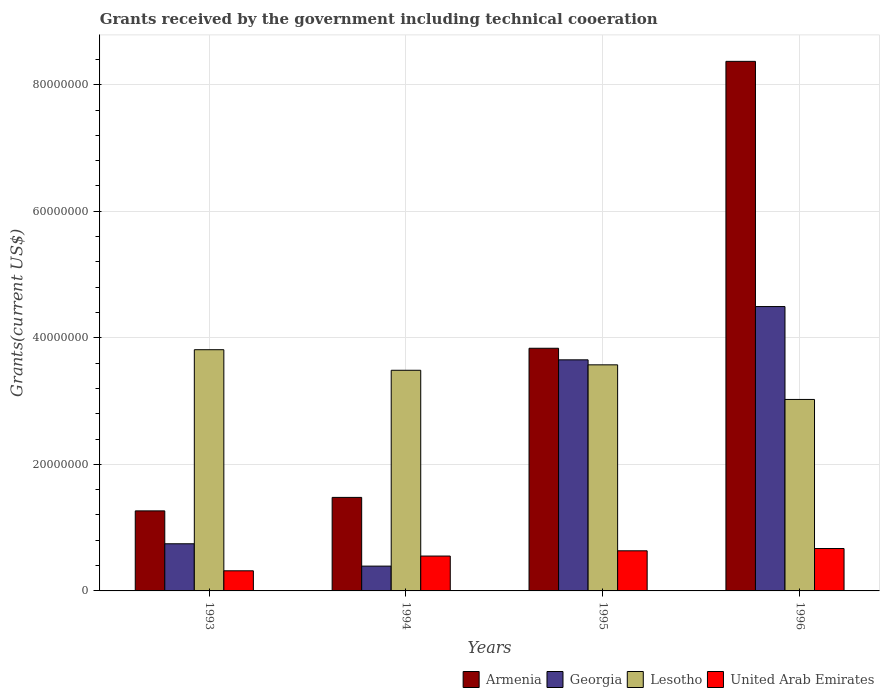How many different coloured bars are there?
Provide a succinct answer. 4. Are the number of bars on each tick of the X-axis equal?
Provide a succinct answer. Yes. What is the label of the 1st group of bars from the left?
Provide a short and direct response. 1993. In how many cases, is the number of bars for a given year not equal to the number of legend labels?
Offer a very short reply. 0. What is the total grants received by the government in Armenia in 1994?
Provide a short and direct response. 1.48e+07. Across all years, what is the maximum total grants received by the government in Lesotho?
Ensure brevity in your answer.  3.81e+07. Across all years, what is the minimum total grants received by the government in Armenia?
Keep it short and to the point. 1.26e+07. What is the total total grants received by the government in Armenia in the graph?
Ensure brevity in your answer.  1.49e+08. What is the difference between the total grants received by the government in United Arab Emirates in 1993 and that in 1996?
Provide a short and direct response. -3.52e+06. What is the difference between the total grants received by the government in United Arab Emirates in 1996 and the total grants received by the government in Armenia in 1994?
Your answer should be compact. -8.08e+06. What is the average total grants received by the government in Armenia per year?
Your answer should be compact. 3.74e+07. In the year 1993, what is the difference between the total grants received by the government in Georgia and total grants received by the government in Lesotho?
Keep it short and to the point. -3.07e+07. What is the ratio of the total grants received by the government in Lesotho in 1993 to that in 1996?
Provide a succinct answer. 1.26. Is the difference between the total grants received by the government in Georgia in 1993 and 1995 greater than the difference between the total grants received by the government in Lesotho in 1993 and 1995?
Provide a succinct answer. No. What is the difference between the highest and the second highest total grants received by the government in Georgia?
Offer a very short reply. 8.42e+06. What is the difference between the highest and the lowest total grants received by the government in Lesotho?
Make the answer very short. 7.86e+06. What does the 4th bar from the left in 1993 represents?
Offer a terse response. United Arab Emirates. What does the 2nd bar from the right in 1993 represents?
Your answer should be compact. Lesotho. Are all the bars in the graph horizontal?
Your response must be concise. No. What is the difference between two consecutive major ticks on the Y-axis?
Your answer should be very brief. 2.00e+07. Are the values on the major ticks of Y-axis written in scientific E-notation?
Offer a terse response. No. Does the graph contain grids?
Ensure brevity in your answer.  Yes. Where does the legend appear in the graph?
Ensure brevity in your answer.  Bottom right. What is the title of the graph?
Give a very brief answer. Grants received by the government including technical cooeration. What is the label or title of the Y-axis?
Your answer should be compact. Grants(current US$). What is the Grants(current US$) of Armenia in 1993?
Give a very brief answer. 1.26e+07. What is the Grants(current US$) in Georgia in 1993?
Make the answer very short. 7.45e+06. What is the Grants(current US$) in Lesotho in 1993?
Your answer should be compact. 3.81e+07. What is the Grants(current US$) of United Arab Emirates in 1993?
Make the answer very short. 3.18e+06. What is the Grants(current US$) in Armenia in 1994?
Offer a very short reply. 1.48e+07. What is the Grants(current US$) in Georgia in 1994?
Offer a terse response. 3.92e+06. What is the Grants(current US$) in Lesotho in 1994?
Your answer should be very brief. 3.49e+07. What is the Grants(current US$) in United Arab Emirates in 1994?
Make the answer very short. 5.51e+06. What is the Grants(current US$) in Armenia in 1995?
Offer a very short reply. 3.84e+07. What is the Grants(current US$) in Georgia in 1995?
Offer a very short reply. 3.65e+07. What is the Grants(current US$) of Lesotho in 1995?
Give a very brief answer. 3.57e+07. What is the Grants(current US$) in United Arab Emirates in 1995?
Offer a terse response. 6.34e+06. What is the Grants(current US$) in Armenia in 1996?
Keep it short and to the point. 8.37e+07. What is the Grants(current US$) in Georgia in 1996?
Your response must be concise. 4.49e+07. What is the Grants(current US$) in Lesotho in 1996?
Offer a very short reply. 3.03e+07. What is the Grants(current US$) in United Arab Emirates in 1996?
Give a very brief answer. 6.70e+06. Across all years, what is the maximum Grants(current US$) in Armenia?
Offer a terse response. 8.37e+07. Across all years, what is the maximum Grants(current US$) in Georgia?
Offer a terse response. 4.49e+07. Across all years, what is the maximum Grants(current US$) in Lesotho?
Provide a succinct answer. 3.81e+07. Across all years, what is the maximum Grants(current US$) of United Arab Emirates?
Make the answer very short. 6.70e+06. Across all years, what is the minimum Grants(current US$) in Armenia?
Provide a succinct answer. 1.26e+07. Across all years, what is the minimum Grants(current US$) of Georgia?
Make the answer very short. 3.92e+06. Across all years, what is the minimum Grants(current US$) of Lesotho?
Provide a short and direct response. 3.03e+07. Across all years, what is the minimum Grants(current US$) of United Arab Emirates?
Give a very brief answer. 3.18e+06. What is the total Grants(current US$) of Armenia in the graph?
Your response must be concise. 1.49e+08. What is the total Grants(current US$) of Georgia in the graph?
Your response must be concise. 9.28e+07. What is the total Grants(current US$) in Lesotho in the graph?
Ensure brevity in your answer.  1.39e+08. What is the total Grants(current US$) in United Arab Emirates in the graph?
Ensure brevity in your answer.  2.17e+07. What is the difference between the Grants(current US$) of Armenia in 1993 and that in 1994?
Provide a succinct answer. -2.13e+06. What is the difference between the Grants(current US$) in Georgia in 1993 and that in 1994?
Your answer should be compact. 3.53e+06. What is the difference between the Grants(current US$) in Lesotho in 1993 and that in 1994?
Offer a terse response. 3.25e+06. What is the difference between the Grants(current US$) of United Arab Emirates in 1993 and that in 1994?
Your response must be concise. -2.33e+06. What is the difference between the Grants(current US$) in Armenia in 1993 and that in 1995?
Your answer should be compact. -2.57e+07. What is the difference between the Grants(current US$) in Georgia in 1993 and that in 1995?
Offer a terse response. -2.91e+07. What is the difference between the Grants(current US$) in Lesotho in 1993 and that in 1995?
Make the answer very short. 2.39e+06. What is the difference between the Grants(current US$) of United Arab Emirates in 1993 and that in 1995?
Provide a short and direct response. -3.16e+06. What is the difference between the Grants(current US$) in Armenia in 1993 and that in 1996?
Keep it short and to the point. -7.10e+07. What is the difference between the Grants(current US$) of Georgia in 1993 and that in 1996?
Keep it short and to the point. -3.75e+07. What is the difference between the Grants(current US$) of Lesotho in 1993 and that in 1996?
Offer a very short reply. 7.86e+06. What is the difference between the Grants(current US$) in United Arab Emirates in 1993 and that in 1996?
Give a very brief answer. -3.52e+06. What is the difference between the Grants(current US$) of Armenia in 1994 and that in 1995?
Provide a succinct answer. -2.36e+07. What is the difference between the Grants(current US$) of Georgia in 1994 and that in 1995?
Offer a very short reply. -3.26e+07. What is the difference between the Grants(current US$) of Lesotho in 1994 and that in 1995?
Your response must be concise. -8.60e+05. What is the difference between the Grants(current US$) of United Arab Emirates in 1994 and that in 1995?
Provide a short and direct response. -8.30e+05. What is the difference between the Grants(current US$) in Armenia in 1994 and that in 1996?
Give a very brief answer. -6.89e+07. What is the difference between the Grants(current US$) in Georgia in 1994 and that in 1996?
Offer a very short reply. -4.10e+07. What is the difference between the Grants(current US$) in Lesotho in 1994 and that in 1996?
Give a very brief answer. 4.61e+06. What is the difference between the Grants(current US$) of United Arab Emirates in 1994 and that in 1996?
Provide a succinct answer. -1.19e+06. What is the difference between the Grants(current US$) in Armenia in 1995 and that in 1996?
Your answer should be very brief. -4.53e+07. What is the difference between the Grants(current US$) in Georgia in 1995 and that in 1996?
Your answer should be very brief. -8.42e+06. What is the difference between the Grants(current US$) of Lesotho in 1995 and that in 1996?
Provide a succinct answer. 5.47e+06. What is the difference between the Grants(current US$) of United Arab Emirates in 1995 and that in 1996?
Ensure brevity in your answer.  -3.60e+05. What is the difference between the Grants(current US$) in Armenia in 1993 and the Grants(current US$) in Georgia in 1994?
Your response must be concise. 8.73e+06. What is the difference between the Grants(current US$) in Armenia in 1993 and the Grants(current US$) in Lesotho in 1994?
Offer a terse response. -2.22e+07. What is the difference between the Grants(current US$) in Armenia in 1993 and the Grants(current US$) in United Arab Emirates in 1994?
Give a very brief answer. 7.14e+06. What is the difference between the Grants(current US$) in Georgia in 1993 and the Grants(current US$) in Lesotho in 1994?
Offer a very short reply. -2.74e+07. What is the difference between the Grants(current US$) in Georgia in 1993 and the Grants(current US$) in United Arab Emirates in 1994?
Your answer should be compact. 1.94e+06. What is the difference between the Grants(current US$) of Lesotho in 1993 and the Grants(current US$) of United Arab Emirates in 1994?
Your answer should be very brief. 3.26e+07. What is the difference between the Grants(current US$) in Armenia in 1993 and the Grants(current US$) in Georgia in 1995?
Make the answer very short. -2.39e+07. What is the difference between the Grants(current US$) in Armenia in 1993 and the Grants(current US$) in Lesotho in 1995?
Provide a succinct answer. -2.31e+07. What is the difference between the Grants(current US$) of Armenia in 1993 and the Grants(current US$) of United Arab Emirates in 1995?
Your answer should be compact. 6.31e+06. What is the difference between the Grants(current US$) of Georgia in 1993 and the Grants(current US$) of Lesotho in 1995?
Ensure brevity in your answer.  -2.83e+07. What is the difference between the Grants(current US$) of Georgia in 1993 and the Grants(current US$) of United Arab Emirates in 1995?
Make the answer very short. 1.11e+06. What is the difference between the Grants(current US$) of Lesotho in 1993 and the Grants(current US$) of United Arab Emirates in 1995?
Make the answer very short. 3.18e+07. What is the difference between the Grants(current US$) in Armenia in 1993 and the Grants(current US$) in Georgia in 1996?
Provide a short and direct response. -3.23e+07. What is the difference between the Grants(current US$) of Armenia in 1993 and the Grants(current US$) of Lesotho in 1996?
Ensure brevity in your answer.  -1.76e+07. What is the difference between the Grants(current US$) in Armenia in 1993 and the Grants(current US$) in United Arab Emirates in 1996?
Provide a succinct answer. 5.95e+06. What is the difference between the Grants(current US$) in Georgia in 1993 and the Grants(current US$) in Lesotho in 1996?
Your answer should be very brief. -2.28e+07. What is the difference between the Grants(current US$) of Georgia in 1993 and the Grants(current US$) of United Arab Emirates in 1996?
Provide a short and direct response. 7.50e+05. What is the difference between the Grants(current US$) in Lesotho in 1993 and the Grants(current US$) in United Arab Emirates in 1996?
Ensure brevity in your answer.  3.14e+07. What is the difference between the Grants(current US$) in Armenia in 1994 and the Grants(current US$) in Georgia in 1995?
Offer a very short reply. -2.17e+07. What is the difference between the Grants(current US$) in Armenia in 1994 and the Grants(current US$) in Lesotho in 1995?
Make the answer very short. -2.10e+07. What is the difference between the Grants(current US$) of Armenia in 1994 and the Grants(current US$) of United Arab Emirates in 1995?
Your answer should be very brief. 8.44e+06. What is the difference between the Grants(current US$) of Georgia in 1994 and the Grants(current US$) of Lesotho in 1995?
Your response must be concise. -3.18e+07. What is the difference between the Grants(current US$) in Georgia in 1994 and the Grants(current US$) in United Arab Emirates in 1995?
Provide a short and direct response. -2.42e+06. What is the difference between the Grants(current US$) of Lesotho in 1994 and the Grants(current US$) of United Arab Emirates in 1995?
Your answer should be compact. 2.85e+07. What is the difference between the Grants(current US$) of Armenia in 1994 and the Grants(current US$) of Georgia in 1996?
Ensure brevity in your answer.  -3.02e+07. What is the difference between the Grants(current US$) in Armenia in 1994 and the Grants(current US$) in Lesotho in 1996?
Make the answer very short. -1.55e+07. What is the difference between the Grants(current US$) in Armenia in 1994 and the Grants(current US$) in United Arab Emirates in 1996?
Give a very brief answer. 8.08e+06. What is the difference between the Grants(current US$) in Georgia in 1994 and the Grants(current US$) in Lesotho in 1996?
Make the answer very short. -2.63e+07. What is the difference between the Grants(current US$) of Georgia in 1994 and the Grants(current US$) of United Arab Emirates in 1996?
Keep it short and to the point. -2.78e+06. What is the difference between the Grants(current US$) of Lesotho in 1994 and the Grants(current US$) of United Arab Emirates in 1996?
Keep it short and to the point. 2.82e+07. What is the difference between the Grants(current US$) of Armenia in 1995 and the Grants(current US$) of Georgia in 1996?
Offer a very short reply. -6.59e+06. What is the difference between the Grants(current US$) of Armenia in 1995 and the Grants(current US$) of Lesotho in 1996?
Make the answer very short. 8.09e+06. What is the difference between the Grants(current US$) of Armenia in 1995 and the Grants(current US$) of United Arab Emirates in 1996?
Offer a very short reply. 3.16e+07. What is the difference between the Grants(current US$) of Georgia in 1995 and the Grants(current US$) of Lesotho in 1996?
Provide a short and direct response. 6.26e+06. What is the difference between the Grants(current US$) of Georgia in 1995 and the Grants(current US$) of United Arab Emirates in 1996?
Ensure brevity in your answer.  2.98e+07. What is the difference between the Grants(current US$) in Lesotho in 1995 and the Grants(current US$) in United Arab Emirates in 1996?
Offer a terse response. 2.90e+07. What is the average Grants(current US$) in Armenia per year?
Offer a terse response. 3.74e+07. What is the average Grants(current US$) of Georgia per year?
Offer a terse response. 2.32e+07. What is the average Grants(current US$) of Lesotho per year?
Ensure brevity in your answer.  3.47e+07. What is the average Grants(current US$) of United Arab Emirates per year?
Provide a succinct answer. 5.43e+06. In the year 1993, what is the difference between the Grants(current US$) of Armenia and Grants(current US$) of Georgia?
Your answer should be very brief. 5.20e+06. In the year 1993, what is the difference between the Grants(current US$) of Armenia and Grants(current US$) of Lesotho?
Provide a succinct answer. -2.55e+07. In the year 1993, what is the difference between the Grants(current US$) of Armenia and Grants(current US$) of United Arab Emirates?
Make the answer very short. 9.47e+06. In the year 1993, what is the difference between the Grants(current US$) of Georgia and Grants(current US$) of Lesotho?
Your response must be concise. -3.07e+07. In the year 1993, what is the difference between the Grants(current US$) in Georgia and Grants(current US$) in United Arab Emirates?
Offer a terse response. 4.27e+06. In the year 1993, what is the difference between the Grants(current US$) of Lesotho and Grants(current US$) of United Arab Emirates?
Offer a terse response. 3.49e+07. In the year 1994, what is the difference between the Grants(current US$) in Armenia and Grants(current US$) in Georgia?
Provide a short and direct response. 1.09e+07. In the year 1994, what is the difference between the Grants(current US$) in Armenia and Grants(current US$) in Lesotho?
Provide a succinct answer. -2.01e+07. In the year 1994, what is the difference between the Grants(current US$) of Armenia and Grants(current US$) of United Arab Emirates?
Offer a very short reply. 9.27e+06. In the year 1994, what is the difference between the Grants(current US$) in Georgia and Grants(current US$) in Lesotho?
Ensure brevity in your answer.  -3.10e+07. In the year 1994, what is the difference between the Grants(current US$) of Georgia and Grants(current US$) of United Arab Emirates?
Give a very brief answer. -1.59e+06. In the year 1994, what is the difference between the Grants(current US$) of Lesotho and Grants(current US$) of United Arab Emirates?
Offer a terse response. 2.94e+07. In the year 1995, what is the difference between the Grants(current US$) in Armenia and Grants(current US$) in Georgia?
Offer a very short reply. 1.83e+06. In the year 1995, what is the difference between the Grants(current US$) of Armenia and Grants(current US$) of Lesotho?
Your response must be concise. 2.62e+06. In the year 1995, what is the difference between the Grants(current US$) in Armenia and Grants(current US$) in United Arab Emirates?
Provide a short and direct response. 3.20e+07. In the year 1995, what is the difference between the Grants(current US$) in Georgia and Grants(current US$) in Lesotho?
Ensure brevity in your answer.  7.90e+05. In the year 1995, what is the difference between the Grants(current US$) of Georgia and Grants(current US$) of United Arab Emirates?
Give a very brief answer. 3.02e+07. In the year 1995, what is the difference between the Grants(current US$) of Lesotho and Grants(current US$) of United Arab Emirates?
Ensure brevity in your answer.  2.94e+07. In the year 1996, what is the difference between the Grants(current US$) of Armenia and Grants(current US$) of Georgia?
Your response must be concise. 3.88e+07. In the year 1996, what is the difference between the Grants(current US$) in Armenia and Grants(current US$) in Lesotho?
Your answer should be very brief. 5.34e+07. In the year 1996, what is the difference between the Grants(current US$) of Armenia and Grants(current US$) of United Arab Emirates?
Keep it short and to the point. 7.70e+07. In the year 1996, what is the difference between the Grants(current US$) of Georgia and Grants(current US$) of Lesotho?
Ensure brevity in your answer.  1.47e+07. In the year 1996, what is the difference between the Grants(current US$) in Georgia and Grants(current US$) in United Arab Emirates?
Offer a very short reply. 3.82e+07. In the year 1996, what is the difference between the Grants(current US$) in Lesotho and Grants(current US$) in United Arab Emirates?
Your answer should be compact. 2.36e+07. What is the ratio of the Grants(current US$) in Armenia in 1993 to that in 1994?
Provide a succinct answer. 0.86. What is the ratio of the Grants(current US$) in Georgia in 1993 to that in 1994?
Offer a terse response. 1.9. What is the ratio of the Grants(current US$) in Lesotho in 1993 to that in 1994?
Ensure brevity in your answer.  1.09. What is the ratio of the Grants(current US$) in United Arab Emirates in 1993 to that in 1994?
Make the answer very short. 0.58. What is the ratio of the Grants(current US$) of Armenia in 1993 to that in 1995?
Provide a short and direct response. 0.33. What is the ratio of the Grants(current US$) of Georgia in 1993 to that in 1995?
Keep it short and to the point. 0.2. What is the ratio of the Grants(current US$) of Lesotho in 1993 to that in 1995?
Your response must be concise. 1.07. What is the ratio of the Grants(current US$) of United Arab Emirates in 1993 to that in 1995?
Give a very brief answer. 0.5. What is the ratio of the Grants(current US$) in Armenia in 1993 to that in 1996?
Make the answer very short. 0.15. What is the ratio of the Grants(current US$) in Georgia in 1993 to that in 1996?
Provide a short and direct response. 0.17. What is the ratio of the Grants(current US$) in Lesotho in 1993 to that in 1996?
Make the answer very short. 1.26. What is the ratio of the Grants(current US$) in United Arab Emirates in 1993 to that in 1996?
Ensure brevity in your answer.  0.47. What is the ratio of the Grants(current US$) in Armenia in 1994 to that in 1995?
Provide a short and direct response. 0.39. What is the ratio of the Grants(current US$) in Georgia in 1994 to that in 1995?
Offer a very short reply. 0.11. What is the ratio of the Grants(current US$) of Lesotho in 1994 to that in 1995?
Your answer should be compact. 0.98. What is the ratio of the Grants(current US$) of United Arab Emirates in 1994 to that in 1995?
Keep it short and to the point. 0.87. What is the ratio of the Grants(current US$) in Armenia in 1994 to that in 1996?
Give a very brief answer. 0.18. What is the ratio of the Grants(current US$) of Georgia in 1994 to that in 1996?
Ensure brevity in your answer.  0.09. What is the ratio of the Grants(current US$) of Lesotho in 1994 to that in 1996?
Provide a succinct answer. 1.15. What is the ratio of the Grants(current US$) in United Arab Emirates in 1994 to that in 1996?
Your answer should be very brief. 0.82. What is the ratio of the Grants(current US$) in Armenia in 1995 to that in 1996?
Your answer should be compact. 0.46. What is the ratio of the Grants(current US$) in Georgia in 1995 to that in 1996?
Your response must be concise. 0.81. What is the ratio of the Grants(current US$) of Lesotho in 1995 to that in 1996?
Provide a succinct answer. 1.18. What is the ratio of the Grants(current US$) in United Arab Emirates in 1995 to that in 1996?
Provide a short and direct response. 0.95. What is the difference between the highest and the second highest Grants(current US$) in Armenia?
Provide a succinct answer. 4.53e+07. What is the difference between the highest and the second highest Grants(current US$) in Georgia?
Ensure brevity in your answer.  8.42e+06. What is the difference between the highest and the second highest Grants(current US$) of Lesotho?
Your response must be concise. 2.39e+06. What is the difference between the highest and the lowest Grants(current US$) of Armenia?
Give a very brief answer. 7.10e+07. What is the difference between the highest and the lowest Grants(current US$) of Georgia?
Give a very brief answer. 4.10e+07. What is the difference between the highest and the lowest Grants(current US$) in Lesotho?
Your answer should be very brief. 7.86e+06. What is the difference between the highest and the lowest Grants(current US$) of United Arab Emirates?
Provide a short and direct response. 3.52e+06. 